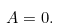<formula> <loc_0><loc_0><loc_500><loc_500>A = 0 .</formula> 